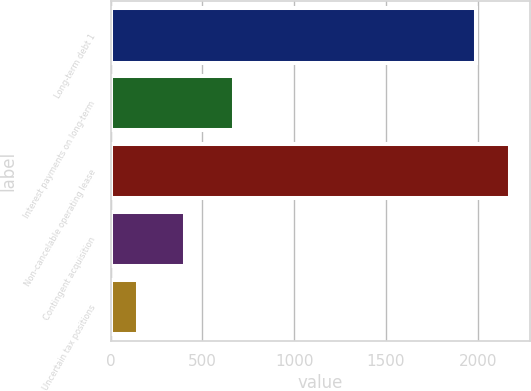<chart> <loc_0><loc_0><loc_500><loc_500><bar_chart><fcel>Long-term debt 1<fcel>Interest payments on long-term<fcel>Non-cancelable operating lease<fcel>Contingent acquisition<fcel>Uncertain tax positions<nl><fcel>1988.1<fcel>673<fcel>2177.03<fcel>402.8<fcel>148.8<nl></chart> 